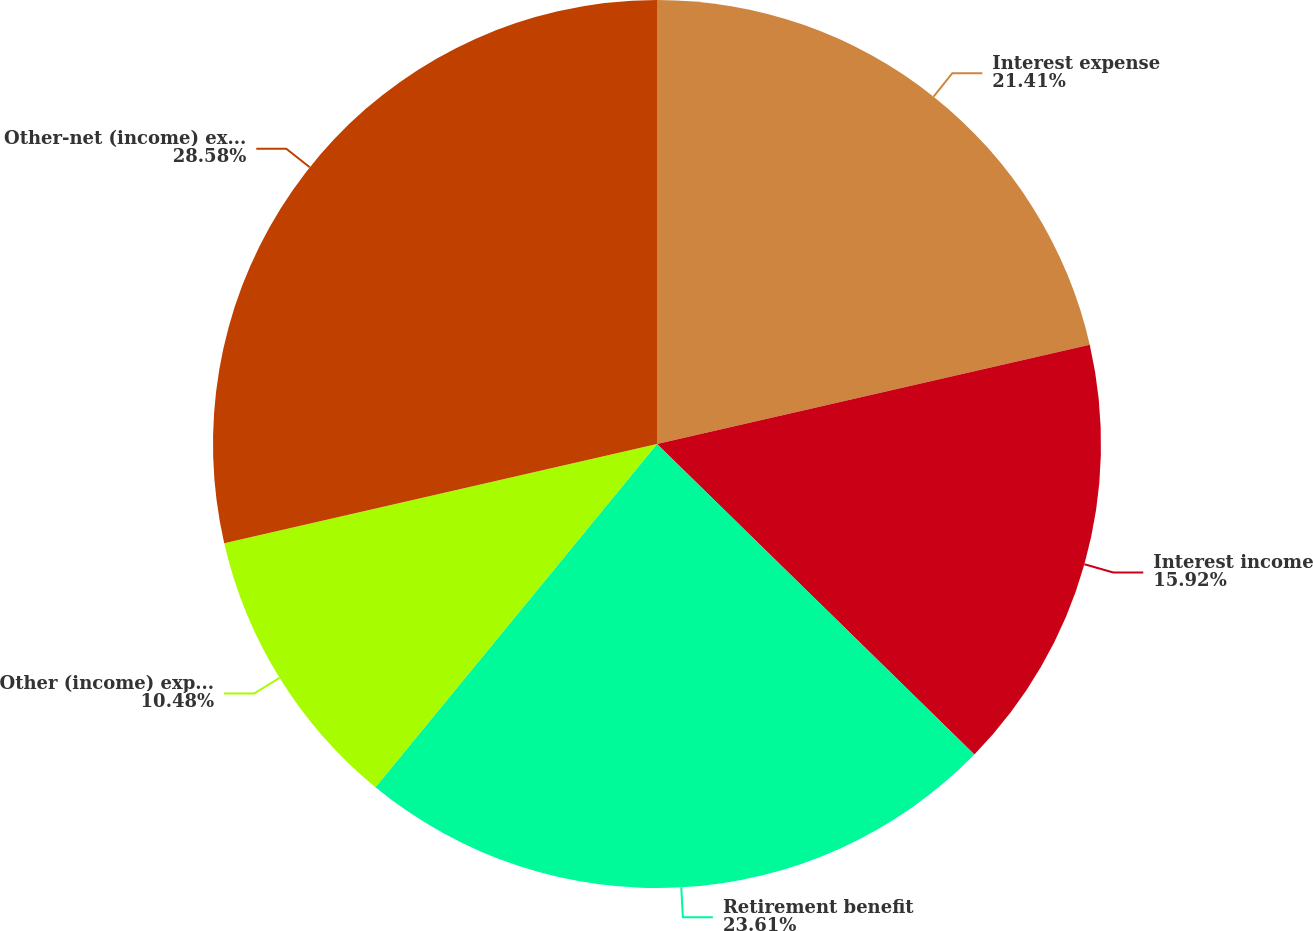Convert chart. <chart><loc_0><loc_0><loc_500><loc_500><pie_chart><fcel>Interest expense<fcel>Interest income<fcel>Retirement benefit<fcel>Other (income) expense<fcel>Other-net (income) expense<nl><fcel>21.41%<fcel>15.92%<fcel>23.61%<fcel>10.48%<fcel>28.59%<nl></chart> 